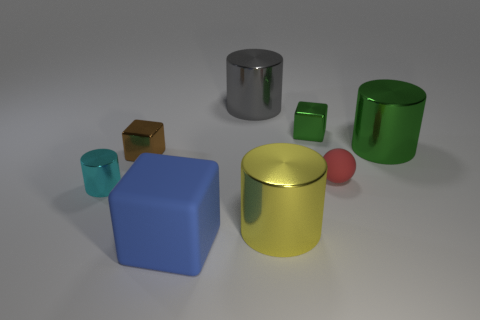The brown object that is the same size as the cyan cylinder is what shape?
Ensure brevity in your answer.  Cube. There is a cube that is made of the same material as the tiny green thing; what color is it?
Make the answer very short. Brown. Is the number of blue matte cubes greater than the number of cubes?
Your answer should be very brief. No. There is a cylinder that is to the right of the small shiny cylinder and in front of the big green shiny cylinder; what is its size?
Provide a short and direct response. Large. Is the number of brown shiny blocks on the right side of the small green thing the same as the number of tiny cylinders?
Offer a terse response. No. Do the brown metallic cube and the red thing have the same size?
Offer a very short reply. Yes. There is a large thing that is both in front of the tiny red ball and behind the blue rubber thing; what color is it?
Keep it short and to the point. Yellow. There is a small block right of the rubber object in front of the small cyan metal cylinder; what is it made of?
Your response must be concise. Metal. The blue rubber thing that is the same shape as the brown metallic thing is what size?
Your answer should be very brief. Large. There is a thing on the right side of the tiny red matte ball; is it the same color as the small rubber object?
Give a very brief answer. No. 